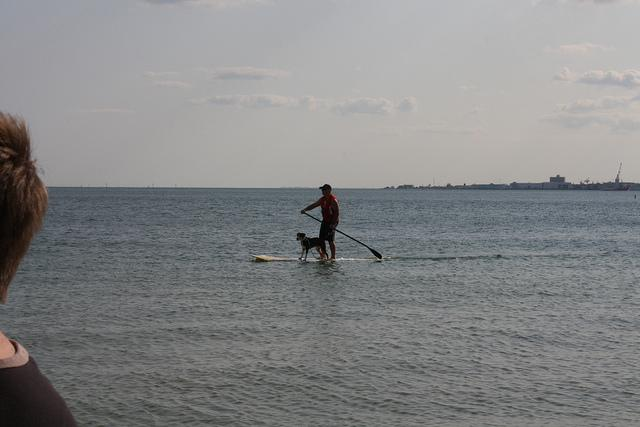What type of vehicle is present in the water? boat 